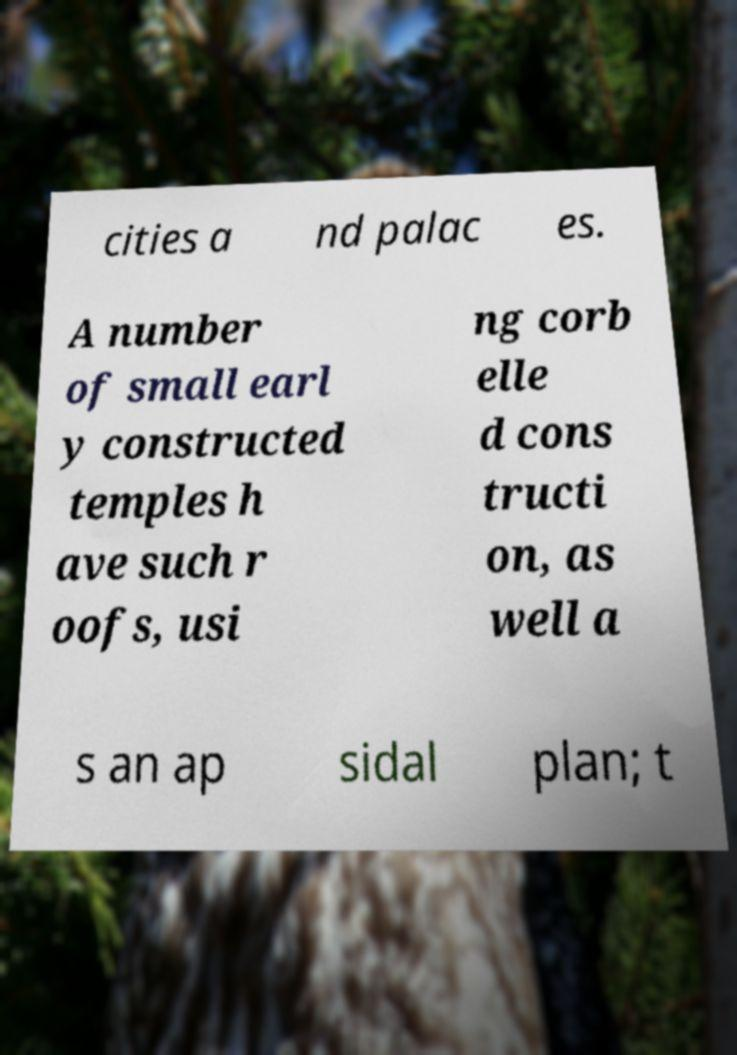For documentation purposes, I need the text within this image transcribed. Could you provide that? cities a nd palac es. A number of small earl y constructed temples h ave such r oofs, usi ng corb elle d cons tructi on, as well a s an ap sidal plan; t 